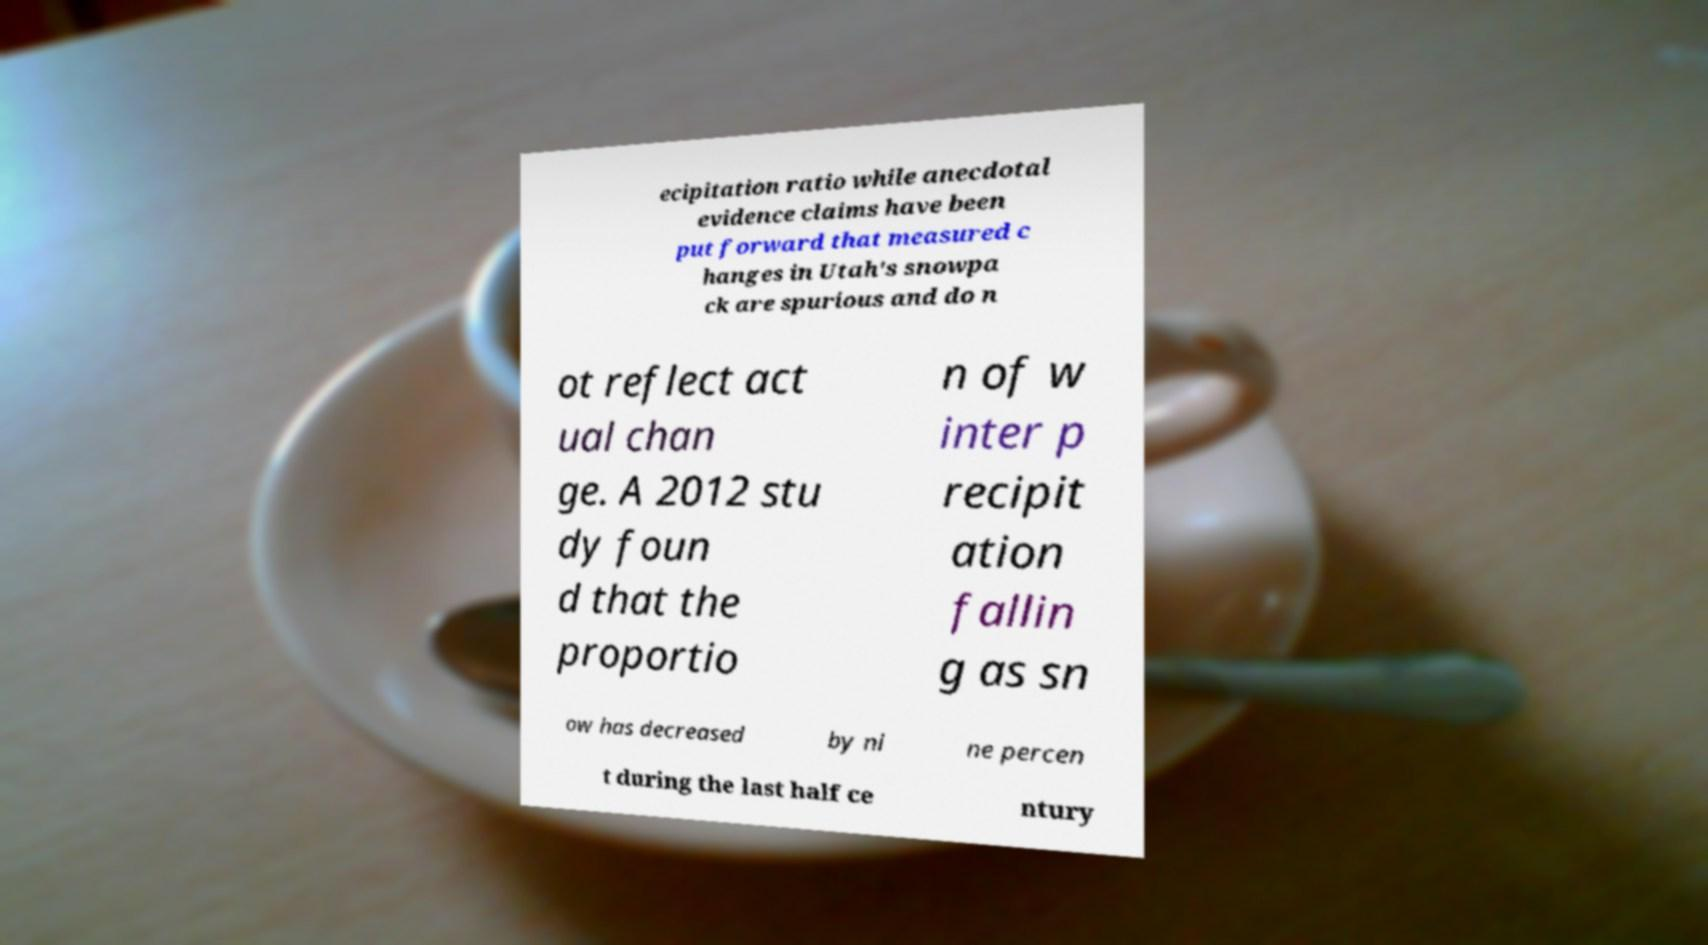What messages or text are displayed in this image? I need them in a readable, typed format. ecipitation ratio while anecdotal evidence claims have been put forward that measured c hanges in Utah's snowpa ck are spurious and do n ot reflect act ual chan ge. A 2012 stu dy foun d that the proportio n of w inter p recipit ation fallin g as sn ow has decreased by ni ne percen t during the last half ce ntury 